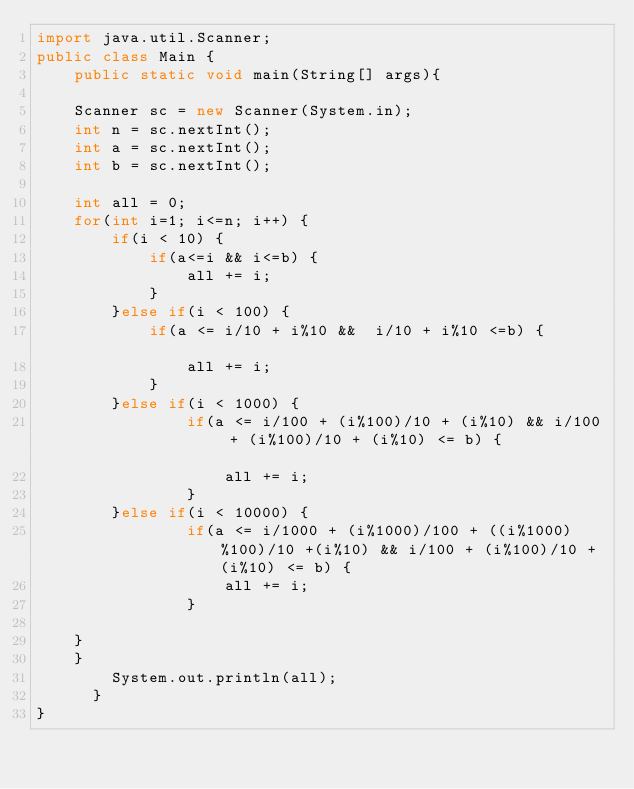<code> <loc_0><loc_0><loc_500><loc_500><_Java_>import java.util.Scanner;
public class Main {
    public static void main(String[] args){
    
    Scanner sc = new Scanner(System.in);
    int n = sc.nextInt();
    int a = sc.nextInt();
    int b = sc.nextInt();
    
    int all = 0;
    for(int i=1; i<=n; i++) {
    	if(i < 10) {
    		if(a<=i && i<=b) {
    			all += i;
    		}
    	}else if(i < 100) {
    		if(a <= i/10 + i%10	&&	i/10 + i%10	<=b) {				
    			all += i;
    		}
        }else if(i < 1000) {
        		if(a <= i/100 + (i%100)/10 + (i%10)	&& i/100 + (i%100)/10 + (i%10) <= b) {				
        			all += i;
        		}
        }else if(i < 10000) {
            	if(a <=	i/1000 + (i%1000)/100 + ((i%1000)%100)/10 +(i%10) && i/100 + (i%100)/10 + (i%10) <= b) {
            		all += i;
            	}

    }
    }
    	System.out.println(all);
      }
}
</code> 